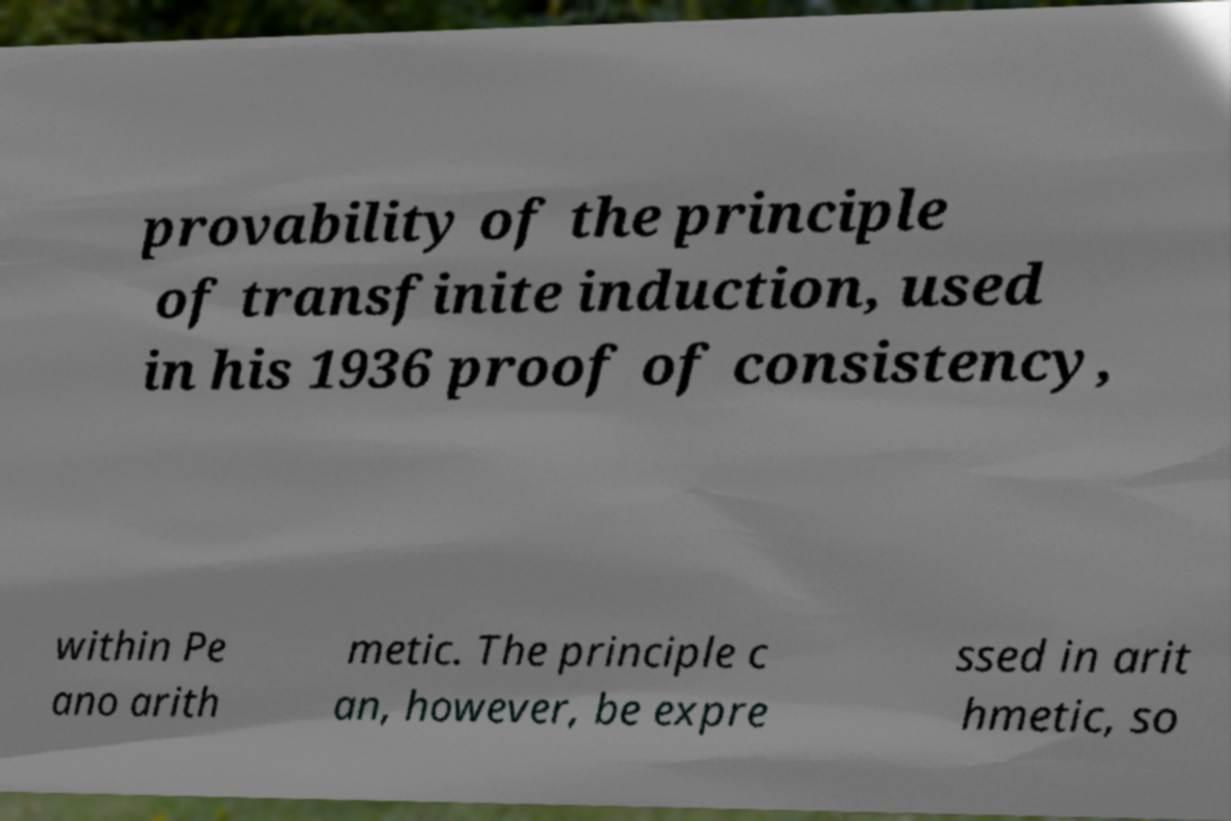Can you read and provide the text displayed in the image?This photo seems to have some interesting text. Can you extract and type it out for me? provability of the principle of transfinite induction, used in his 1936 proof of consistency, within Pe ano arith metic. The principle c an, however, be expre ssed in arit hmetic, so 